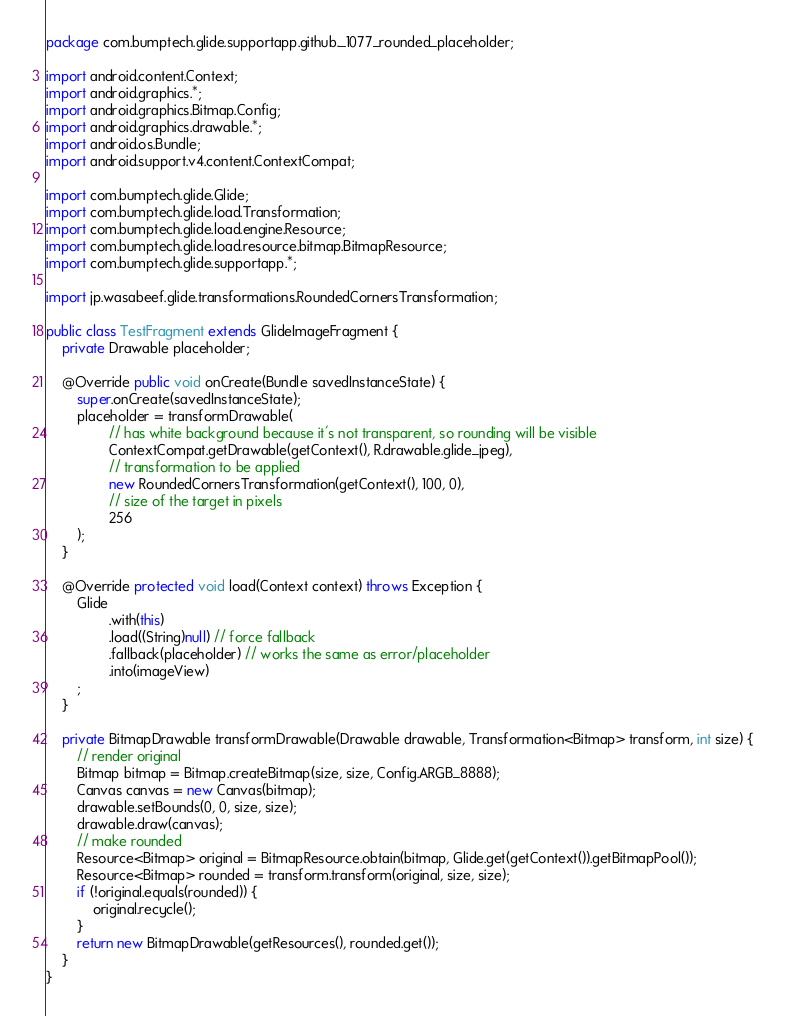Convert code to text. <code><loc_0><loc_0><loc_500><loc_500><_Java_>package com.bumptech.glide.supportapp.github._1077_rounded_placeholder;

import android.content.Context;
import android.graphics.*;
import android.graphics.Bitmap.Config;
import android.graphics.drawable.*;
import android.os.Bundle;
import android.support.v4.content.ContextCompat;

import com.bumptech.glide.Glide;
import com.bumptech.glide.load.Transformation;
import com.bumptech.glide.load.engine.Resource;
import com.bumptech.glide.load.resource.bitmap.BitmapResource;
import com.bumptech.glide.supportapp.*;

import jp.wasabeef.glide.transformations.RoundedCornersTransformation;

public class TestFragment extends GlideImageFragment {
	private Drawable placeholder;

	@Override public void onCreate(Bundle savedInstanceState) {
		super.onCreate(savedInstanceState);
		placeholder = transformDrawable(
				// has white background because it's not transparent, so rounding will be visible
				ContextCompat.getDrawable(getContext(), R.drawable.glide_jpeg),
				// transformation to be applied
				new RoundedCornersTransformation(getContext(), 100, 0),
				// size of the target in pixels
				256
		);
	}

	@Override protected void load(Context context) throws Exception {
		Glide
				.with(this)
				.load((String)null) // force fallback
				.fallback(placeholder) // works the same as error/placeholder
				.into(imageView)
		;
	}

	private BitmapDrawable transformDrawable(Drawable drawable, Transformation<Bitmap> transform, int size) {
		// render original
		Bitmap bitmap = Bitmap.createBitmap(size, size, Config.ARGB_8888);
		Canvas canvas = new Canvas(bitmap);
		drawable.setBounds(0, 0, size, size);
		drawable.draw(canvas);
		// make rounded
		Resource<Bitmap> original = BitmapResource.obtain(bitmap, Glide.get(getContext()).getBitmapPool());
		Resource<Bitmap> rounded = transform.transform(original, size, size);
		if (!original.equals(rounded)) {
			original.recycle();
		}
		return new BitmapDrawable(getResources(), rounded.get());
	}
}
</code> 